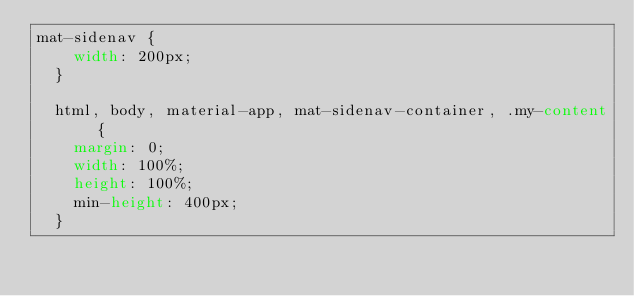<code> <loc_0><loc_0><loc_500><loc_500><_CSS_>mat-sidenav {
    width: 200px;
  }

  html, body, material-app, mat-sidenav-container, .my-content {
    margin: 0;
    width: 100%;
    height: 100%;
    min-height: 400px;
  }</code> 